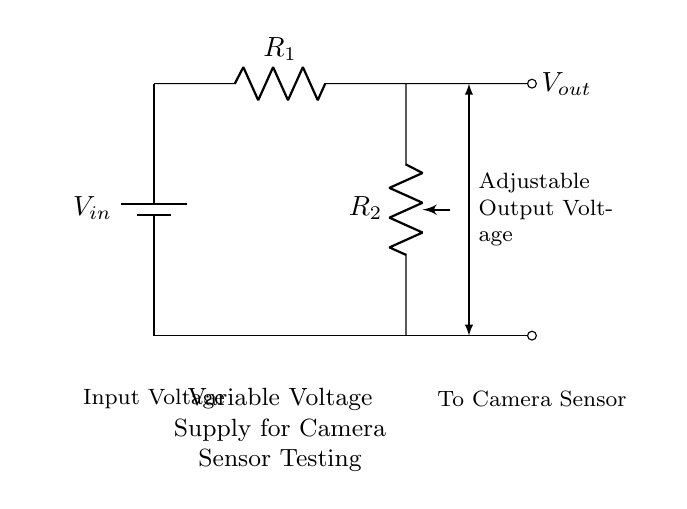What does the potentiometer represent? The potentiometer represents the adjustable resistor R2 in the circuit, allowing for variable voltage output by changing its resistance.
Answer: adjustable resistor What is the role of R1 in the circuit? R1 is a fixed resistor that helps determine the voltage drop across the potentiometer, which affects the output voltage.
Answer: fixed resistor What is the purpose of the voltage output labeled Vout? Vout is the variable output voltage that can be adjusted to test camera sensors at different sensitivity levels.
Answer: variable output voltage What type of circuit is depicted? This is a voltage divider circuit that allows for variable voltage outputs based on the resistances in the circuit.
Answer: voltage divider How would increasing R2 impact Vout? Increasing R2 would proportionally increase the output voltage Vout up to the maximum input voltage, as it changes the division ratio.
Answer: increases Vout What is the input connected to? The input is connected to a battery, supplying the circuit with voltage for the components to function.
Answer: battery What happens if R1 is decreased? Decreasing R1 would result in a higher output voltage Vout, as it changes the voltage division ratio by reducing the total resistance in series.
Answer: higher Vout 